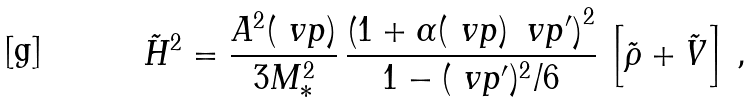Convert formula to latex. <formula><loc_0><loc_0><loc_500><loc_500>\tilde { H } ^ { 2 } = \frac { A ^ { 2 } ( \ v p ) } { 3 M _ { * } ^ { 2 } } \, \frac { \left ( 1 + \alpha ( \ v p ) \, \ v p ^ { \prime } \right ) ^ { 2 } } { 1 - ( \ v p ^ { \prime } ) ^ { 2 } / 6 } \, \left [ \tilde { \rho } + \tilde { V } \right ] \, ,</formula> 